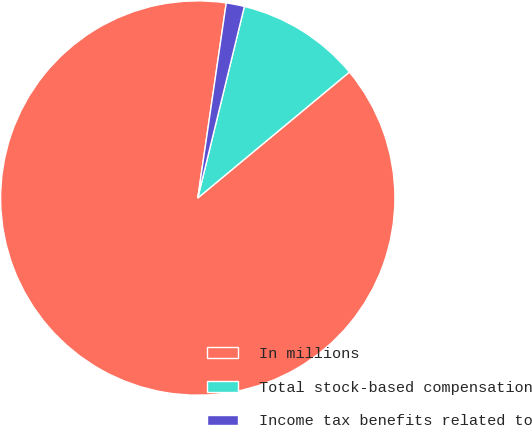Convert chart. <chart><loc_0><loc_0><loc_500><loc_500><pie_chart><fcel>In millions<fcel>Total stock-based compensation<fcel>Income tax benefits related to<nl><fcel>88.34%<fcel>10.17%<fcel>1.49%<nl></chart> 